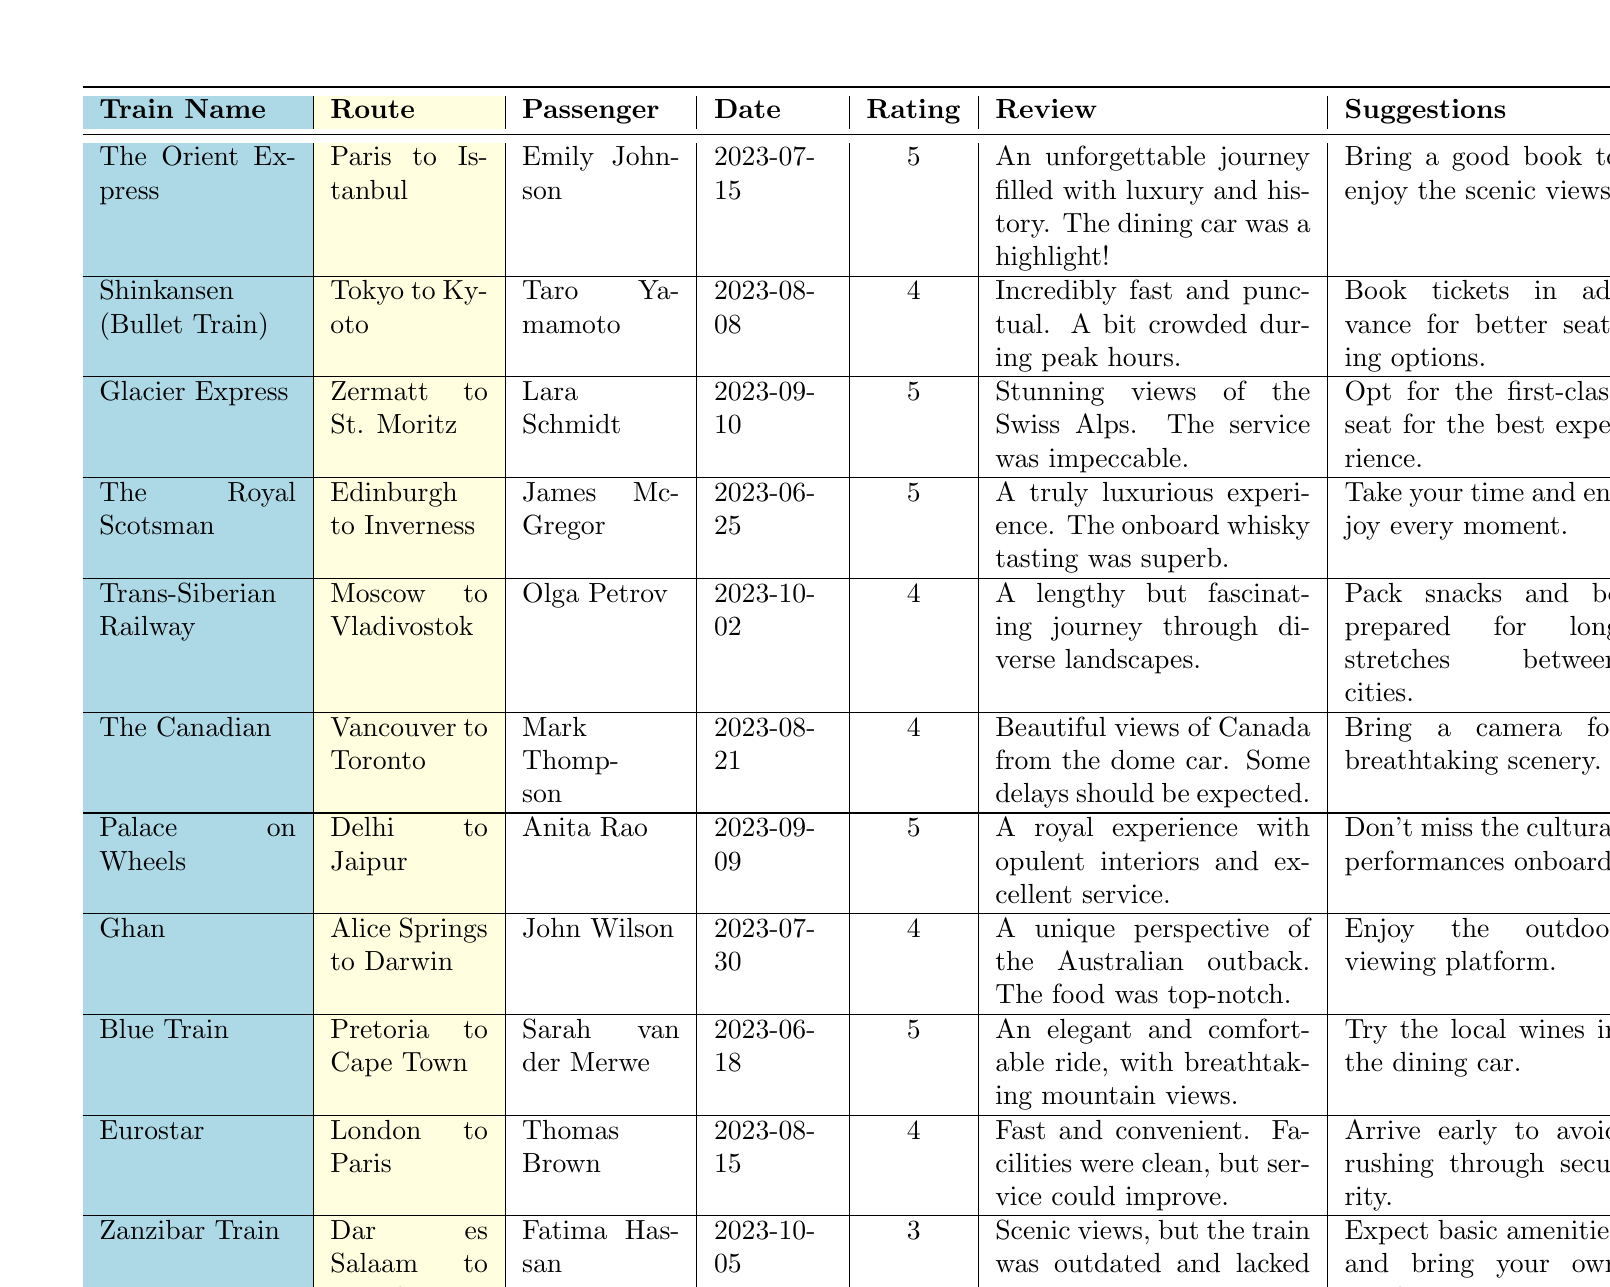What is the highest rating given in the reviews? To find the highest rating, look through the "Rating" column. The ratings are 5, 4, and 3. The highest value among these is 5.
Answer: 5 Which train had the review mentioning "top-notch food"? The review mentioning "top-notch food" is from John Wilson on the Ghan train.
Answer: Ghan How many passengers rated their experience with a score of 4? Count the occurrences of the rating 4 in the "Rating" column. There are three entries with a rating of 4 (Shinkansen, Trans-Siberian Railway, The Canadian, Eurostar).
Answer: 4 Did any passenger suggest bringing a camera? Check the suggestions column to see if any review mentions bringing a camera. Mark Thompson suggested bringing a camera for the Canadian train.
Answer: Yes Which train had the most recent review? The review dates are 2023-10-05 (Zanzibar Train) and 2023-10-02 (Trans-Siberian Railway). The most recent date is for the Zanzibar Train review.
Answer: Zanzibar Train What is the average rating of the Glacier Express, Palace on Wheels, and Blue Train? Add the ratings of the three trains: 5 (Glacier Express) + 5 (Palace on Wheels) + 5 (Blue Train) = 15. Divide by 3 to get the average, which is 15 / 3 = 5.
Answer: 5 Which train had a review that referred to "scenic views"? The review from Fatima Hassan refers to "scenic views" in the context of the Zanzibar Train.
Answer: Zanzibar Train Is there a review that mentions "cultural performances"? Yes, the review by Anita Rao for the Palace on Wheels mentions not to miss the cultural performances onboard.
Answer: Yes What suggestions were given for the Trans-Siberian Railway? The suggestion for the Trans-Siberian Railway from Olga Petrov was to "Pack snacks and be prepared for long stretches between cities."
Answer: Pack snacks How many unique train routes are mentioned in the table? By listing the routes, we have: Paris to Istanbul, Tokyo to Kyoto, Zermatt to St. Moritz, Edinburgh to Inverness, Moscow to Vladivostok, Vancouver to Toronto, Delhi to Jaipur, Alice Springs to Darwin, Pretoria to Cape Town, London to Paris, and Dar es Salaam to Zanzibari, totaling 11 unique routes.
Answer: 11 